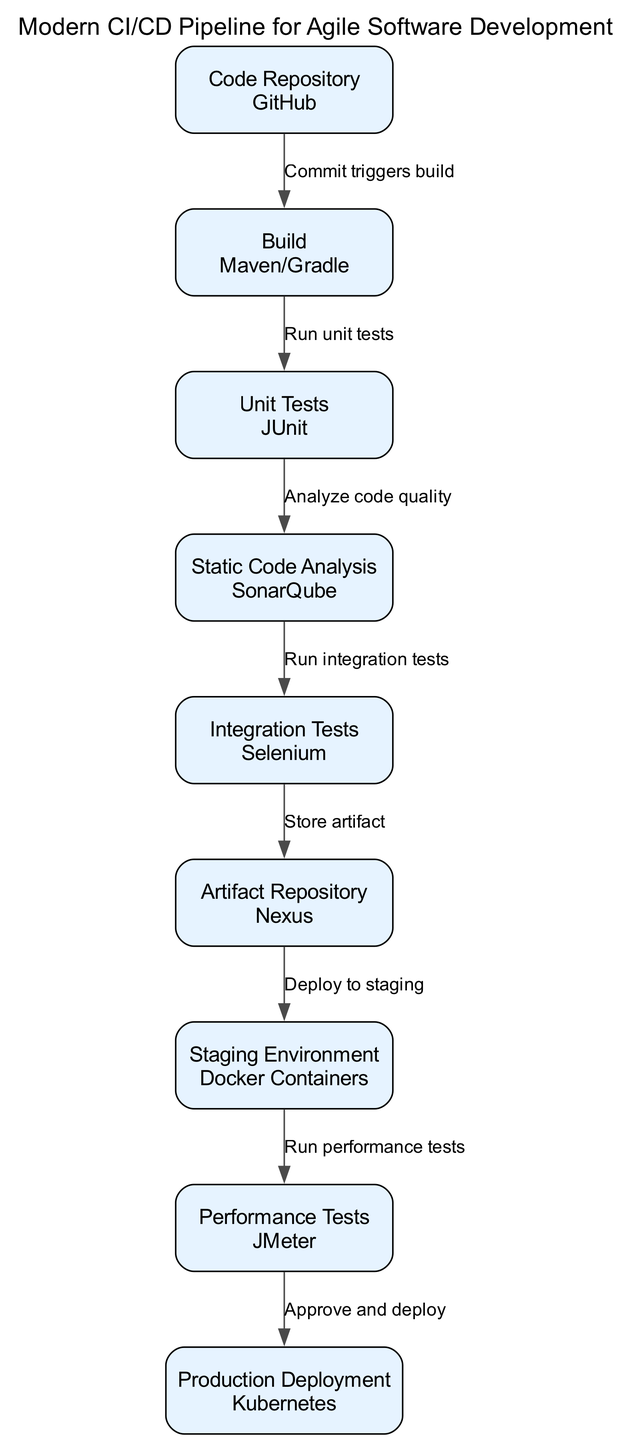What is the first step in the CI/CD pipeline? The first step in the flowchart is represented by the node labeled "Code Repository", which indicates the starting point for the CI/CD process.
Answer: Code Repository How many nodes are in the CI/CD diagram? By counting the nodes listed in the diagram, we find a total of nine distinct nodes.
Answer: 9 What tool is used for unit testing in this pipeline? The diagram indicates that JUnit is the specified tool used for conducting unit tests, as shown in the corresponding node.
Answer: JUnit What happens after unit tests are run? According to the flowchart, after the unit tests are successfully run, the next step is to perform static code analysis, connected by the respective edge.
Answer: Static Code Analysis Which environment is used for performance tests? The diagram specifies that performance tests are conducted in the "Staging Environment", as shown in the flow from the Staging Environment node to the Performance Tests node.
Answer: Staging Environment What node stores the artifacts? The flowchart clearly indicates that artifacts are stored in the node labeled "Artifact Repository." This step follows the integration testing step in the pipeline.
Answer: Artifact Repository What triggers the build process in this pipeline? The build process is triggered by a commit made in the Code Repository, as indicated by the directed edge from the Code Repository node to the Build node.
Answer: Commit Which tool is used for production deployment? The diagram specifies that Kubernetes is the tool used for production deployment, as indicated in the last node of the flowchart.
Answer: Kubernetes What sequence follows after performance testing? The flowchart shows that after performance tests are run, the next action is to approve and deploy, signifying the movement towards production deployment.
Answer: Approve and deploy 